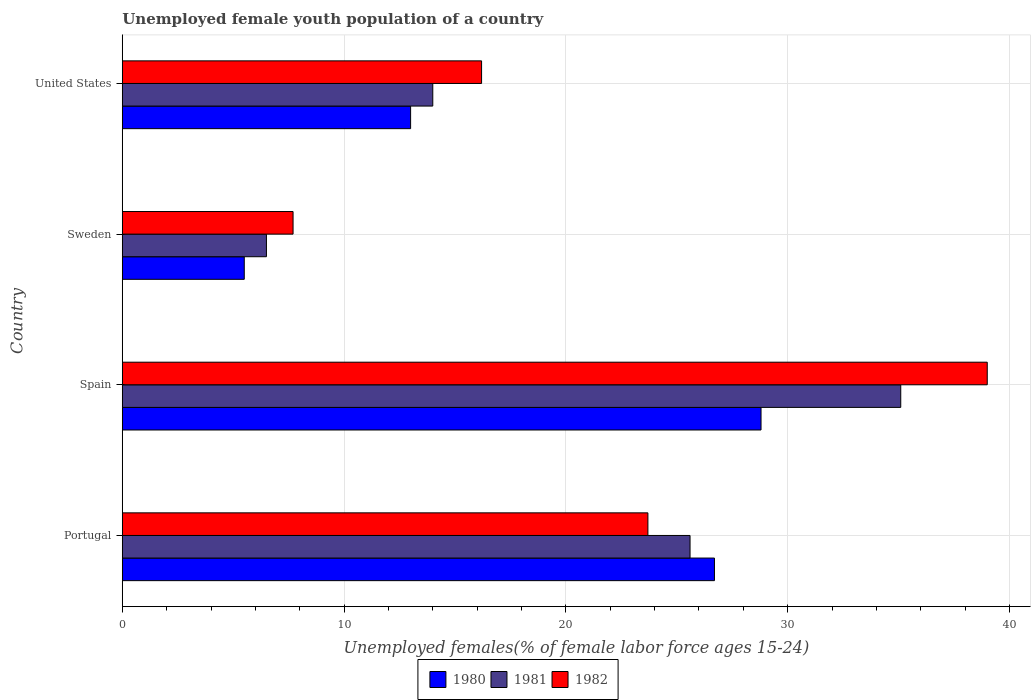How many groups of bars are there?
Offer a terse response. 4. Are the number of bars per tick equal to the number of legend labels?
Keep it short and to the point. Yes. What is the label of the 4th group of bars from the top?
Keep it short and to the point. Portugal. In how many cases, is the number of bars for a given country not equal to the number of legend labels?
Keep it short and to the point. 0. What is the percentage of unemployed female youth population in 1981 in Spain?
Provide a short and direct response. 35.1. Across all countries, what is the maximum percentage of unemployed female youth population in 1981?
Give a very brief answer. 35.1. Across all countries, what is the minimum percentage of unemployed female youth population in 1980?
Provide a succinct answer. 5.5. In which country was the percentage of unemployed female youth population in 1981 maximum?
Your answer should be very brief. Spain. In which country was the percentage of unemployed female youth population in 1981 minimum?
Keep it short and to the point. Sweden. What is the total percentage of unemployed female youth population in 1982 in the graph?
Keep it short and to the point. 86.6. What is the difference between the percentage of unemployed female youth population in 1982 in Spain and that in Sweden?
Keep it short and to the point. 31.3. What is the difference between the percentage of unemployed female youth population in 1981 in United States and the percentage of unemployed female youth population in 1980 in Sweden?
Your answer should be compact. 8.5. What is the difference between the percentage of unemployed female youth population in 1982 and percentage of unemployed female youth population in 1981 in Sweden?
Your response must be concise. 1.2. In how many countries, is the percentage of unemployed female youth population in 1982 greater than 30 %?
Provide a succinct answer. 1. What is the ratio of the percentage of unemployed female youth population in 1980 in Portugal to that in Spain?
Make the answer very short. 0.93. Is the difference between the percentage of unemployed female youth population in 1982 in Spain and Sweden greater than the difference between the percentage of unemployed female youth population in 1981 in Spain and Sweden?
Your response must be concise. Yes. What is the difference between the highest and the second highest percentage of unemployed female youth population in 1982?
Keep it short and to the point. 15.3. What is the difference between the highest and the lowest percentage of unemployed female youth population in 1982?
Provide a succinct answer. 31.3. What does the 2nd bar from the top in Spain represents?
Provide a short and direct response. 1981. How many bars are there?
Offer a very short reply. 12. Are all the bars in the graph horizontal?
Offer a very short reply. Yes. How many countries are there in the graph?
Offer a very short reply. 4. Does the graph contain any zero values?
Your response must be concise. No. Where does the legend appear in the graph?
Give a very brief answer. Bottom center. How are the legend labels stacked?
Your response must be concise. Horizontal. What is the title of the graph?
Offer a terse response. Unemployed female youth population of a country. What is the label or title of the X-axis?
Ensure brevity in your answer.  Unemployed females(% of female labor force ages 15-24). What is the label or title of the Y-axis?
Your answer should be very brief. Country. What is the Unemployed females(% of female labor force ages 15-24) in 1980 in Portugal?
Your response must be concise. 26.7. What is the Unemployed females(% of female labor force ages 15-24) in 1981 in Portugal?
Give a very brief answer. 25.6. What is the Unemployed females(% of female labor force ages 15-24) of 1982 in Portugal?
Offer a terse response. 23.7. What is the Unemployed females(% of female labor force ages 15-24) in 1980 in Spain?
Provide a succinct answer. 28.8. What is the Unemployed females(% of female labor force ages 15-24) of 1981 in Spain?
Ensure brevity in your answer.  35.1. What is the Unemployed females(% of female labor force ages 15-24) in 1982 in Spain?
Offer a very short reply. 39. What is the Unemployed females(% of female labor force ages 15-24) in 1980 in Sweden?
Your answer should be compact. 5.5. What is the Unemployed females(% of female labor force ages 15-24) of 1982 in Sweden?
Keep it short and to the point. 7.7. What is the Unemployed females(% of female labor force ages 15-24) of 1980 in United States?
Your response must be concise. 13. What is the Unemployed females(% of female labor force ages 15-24) of 1981 in United States?
Ensure brevity in your answer.  14. What is the Unemployed females(% of female labor force ages 15-24) of 1982 in United States?
Keep it short and to the point. 16.2. Across all countries, what is the maximum Unemployed females(% of female labor force ages 15-24) of 1980?
Provide a short and direct response. 28.8. Across all countries, what is the maximum Unemployed females(% of female labor force ages 15-24) in 1981?
Keep it short and to the point. 35.1. Across all countries, what is the maximum Unemployed females(% of female labor force ages 15-24) of 1982?
Your response must be concise. 39. Across all countries, what is the minimum Unemployed females(% of female labor force ages 15-24) of 1980?
Your answer should be compact. 5.5. Across all countries, what is the minimum Unemployed females(% of female labor force ages 15-24) in 1982?
Offer a terse response. 7.7. What is the total Unemployed females(% of female labor force ages 15-24) of 1981 in the graph?
Ensure brevity in your answer.  81.2. What is the total Unemployed females(% of female labor force ages 15-24) in 1982 in the graph?
Your answer should be compact. 86.6. What is the difference between the Unemployed females(% of female labor force ages 15-24) of 1980 in Portugal and that in Spain?
Your answer should be compact. -2.1. What is the difference between the Unemployed females(% of female labor force ages 15-24) of 1982 in Portugal and that in Spain?
Your answer should be compact. -15.3. What is the difference between the Unemployed females(% of female labor force ages 15-24) of 1980 in Portugal and that in Sweden?
Your response must be concise. 21.2. What is the difference between the Unemployed females(% of female labor force ages 15-24) of 1981 in Portugal and that in Sweden?
Provide a short and direct response. 19.1. What is the difference between the Unemployed females(% of female labor force ages 15-24) of 1982 in Portugal and that in Sweden?
Offer a terse response. 16. What is the difference between the Unemployed females(% of female labor force ages 15-24) in 1982 in Portugal and that in United States?
Keep it short and to the point. 7.5. What is the difference between the Unemployed females(% of female labor force ages 15-24) of 1980 in Spain and that in Sweden?
Offer a terse response. 23.3. What is the difference between the Unemployed females(% of female labor force ages 15-24) of 1981 in Spain and that in Sweden?
Your answer should be very brief. 28.6. What is the difference between the Unemployed females(% of female labor force ages 15-24) in 1982 in Spain and that in Sweden?
Provide a succinct answer. 31.3. What is the difference between the Unemployed females(% of female labor force ages 15-24) in 1981 in Spain and that in United States?
Your answer should be very brief. 21.1. What is the difference between the Unemployed females(% of female labor force ages 15-24) of 1982 in Spain and that in United States?
Offer a very short reply. 22.8. What is the difference between the Unemployed females(% of female labor force ages 15-24) of 1981 in Sweden and that in United States?
Your answer should be very brief. -7.5. What is the difference between the Unemployed females(% of female labor force ages 15-24) of 1982 in Sweden and that in United States?
Give a very brief answer. -8.5. What is the difference between the Unemployed females(% of female labor force ages 15-24) of 1980 in Portugal and the Unemployed females(% of female labor force ages 15-24) of 1982 in Spain?
Offer a terse response. -12.3. What is the difference between the Unemployed females(% of female labor force ages 15-24) in 1980 in Portugal and the Unemployed females(% of female labor force ages 15-24) in 1981 in Sweden?
Keep it short and to the point. 20.2. What is the difference between the Unemployed females(% of female labor force ages 15-24) of 1981 in Portugal and the Unemployed females(% of female labor force ages 15-24) of 1982 in Sweden?
Provide a succinct answer. 17.9. What is the difference between the Unemployed females(% of female labor force ages 15-24) of 1980 in Spain and the Unemployed females(% of female labor force ages 15-24) of 1981 in Sweden?
Offer a very short reply. 22.3. What is the difference between the Unemployed females(% of female labor force ages 15-24) of 1980 in Spain and the Unemployed females(% of female labor force ages 15-24) of 1982 in Sweden?
Offer a terse response. 21.1. What is the difference between the Unemployed females(% of female labor force ages 15-24) in 1981 in Spain and the Unemployed females(% of female labor force ages 15-24) in 1982 in Sweden?
Offer a very short reply. 27.4. What is the difference between the Unemployed females(% of female labor force ages 15-24) of 1980 in Spain and the Unemployed females(% of female labor force ages 15-24) of 1981 in United States?
Your answer should be compact. 14.8. What is the difference between the Unemployed females(% of female labor force ages 15-24) in 1980 in Sweden and the Unemployed females(% of female labor force ages 15-24) in 1981 in United States?
Provide a short and direct response. -8.5. What is the average Unemployed females(% of female labor force ages 15-24) of 1981 per country?
Make the answer very short. 20.3. What is the average Unemployed females(% of female labor force ages 15-24) in 1982 per country?
Provide a succinct answer. 21.65. What is the difference between the Unemployed females(% of female labor force ages 15-24) of 1980 and Unemployed females(% of female labor force ages 15-24) of 1981 in Portugal?
Offer a terse response. 1.1. What is the difference between the Unemployed females(% of female labor force ages 15-24) in 1980 and Unemployed females(% of female labor force ages 15-24) in 1981 in Spain?
Keep it short and to the point. -6.3. What is the difference between the Unemployed females(% of female labor force ages 15-24) of 1981 and Unemployed females(% of female labor force ages 15-24) of 1982 in Spain?
Your response must be concise. -3.9. What is the difference between the Unemployed females(% of female labor force ages 15-24) in 1980 and Unemployed females(% of female labor force ages 15-24) in 1981 in Sweden?
Your answer should be compact. -1. What is the difference between the Unemployed females(% of female labor force ages 15-24) of 1980 and Unemployed females(% of female labor force ages 15-24) of 1982 in Sweden?
Provide a short and direct response. -2.2. What is the ratio of the Unemployed females(% of female labor force ages 15-24) of 1980 in Portugal to that in Spain?
Make the answer very short. 0.93. What is the ratio of the Unemployed females(% of female labor force ages 15-24) in 1981 in Portugal to that in Spain?
Ensure brevity in your answer.  0.73. What is the ratio of the Unemployed females(% of female labor force ages 15-24) in 1982 in Portugal to that in Spain?
Ensure brevity in your answer.  0.61. What is the ratio of the Unemployed females(% of female labor force ages 15-24) of 1980 in Portugal to that in Sweden?
Your response must be concise. 4.85. What is the ratio of the Unemployed females(% of female labor force ages 15-24) of 1981 in Portugal to that in Sweden?
Keep it short and to the point. 3.94. What is the ratio of the Unemployed females(% of female labor force ages 15-24) in 1982 in Portugal to that in Sweden?
Your answer should be very brief. 3.08. What is the ratio of the Unemployed females(% of female labor force ages 15-24) of 1980 in Portugal to that in United States?
Make the answer very short. 2.05. What is the ratio of the Unemployed females(% of female labor force ages 15-24) of 1981 in Portugal to that in United States?
Make the answer very short. 1.83. What is the ratio of the Unemployed females(% of female labor force ages 15-24) of 1982 in Portugal to that in United States?
Ensure brevity in your answer.  1.46. What is the ratio of the Unemployed females(% of female labor force ages 15-24) in 1980 in Spain to that in Sweden?
Your answer should be very brief. 5.24. What is the ratio of the Unemployed females(% of female labor force ages 15-24) in 1982 in Spain to that in Sweden?
Your response must be concise. 5.06. What is the ratio of the Unemployed females(% of female labor force ages 15-24) of 1980 in Spain to that in United States?
Your response must be concise. 2.22. What is the ratio of the Unemployed females(% of female labor force ages 15-24) in 1981 in Spain to that in United States?
Your response must be concise. 2.51. What is the ratio of the Unemployed females(% of female labor force ages 15-24) in 1982 in Spain to that in United States?
Your answer should be very brief. 2.41. What is the ratio of the Unemployed females(% of female labor force ages 15-24) in 1980 in Sweden to that in United States?
Provide a succinct answer. 0.42. What is the ratio of the Unemployed females(% of female labor force ages 15-24) in 1981 in Sweden to that in United States?
Keep it short and to the point. 0.46. What is the ratio of the Unemployed females(% of female labor force ages 15-24) in 1982 in Sweden to that in United States?
Keep it short and to the point. 0.48. What is the difference between the highest and the second highest Unemployed females(% of female labor force ages 15-24) of 1981?
Give a very brief answer. 9.5. What is the difference between the highest and the second highest Unemployed females(% of female labor force ages 15-24) of 1982?
Ensure brevity in your answer.  15.3. What is the difference between the highest and the lowest Unemployed females(% of female labor force ages 15-24) in 1980?
Provide a short and direct response. 23.3. What is the difference between the highest and the lowest Unemployed females(% of female labor force ages 15-24) of 1981?
Keep it short and to the point. 28.6. What is the difference between the highest and the lowest Unemployed females(% of female labor force ages 15-24) of 1982?
Your response must be concise. 31.3. 